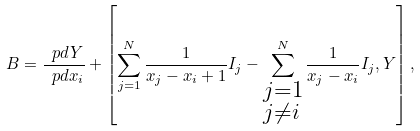Convert formula to latex. <formula><loc_0><loc_0><loc_500><loc_500>B = \frac { \ p d Y } { \ p d x _ { i } } + \left [ \sum _ { j = 1 } ^ { N } \frac { 1 } { x _ { j } - x _ { i } + 1 } I _ { j } - \sum _ { \begin{subarray} { c } j = 1 \\ j \neq i \end{subarray} } ^ { N } \frac { 1 } { x _ { j } - x _ { i } } I _ { j } , Y \right ] ,</formula> 